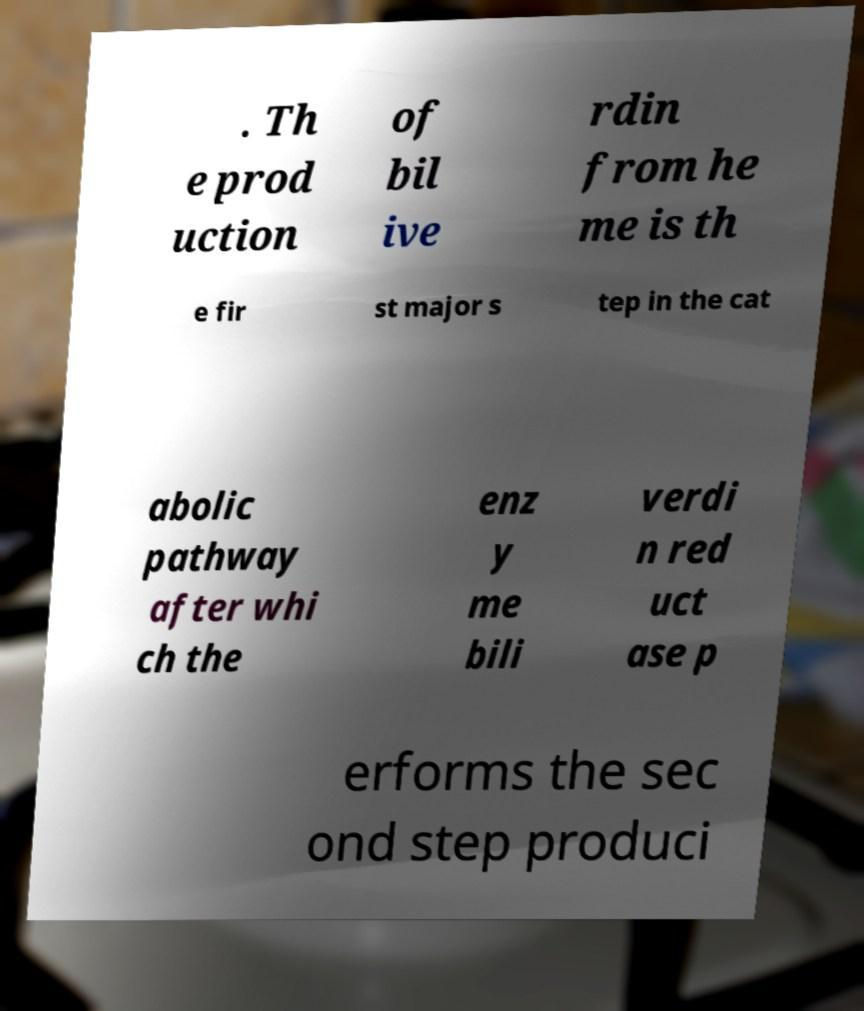There's text embedded in this image that I need extracted. Can you transcribe it verbatim? . Th e prod uction of bil ive rdin from he me is th e fir st major s tep in the cat abolic pathway after whi ch the enz y me bili verdi n red uct ase p erforms the sec ond step produci 